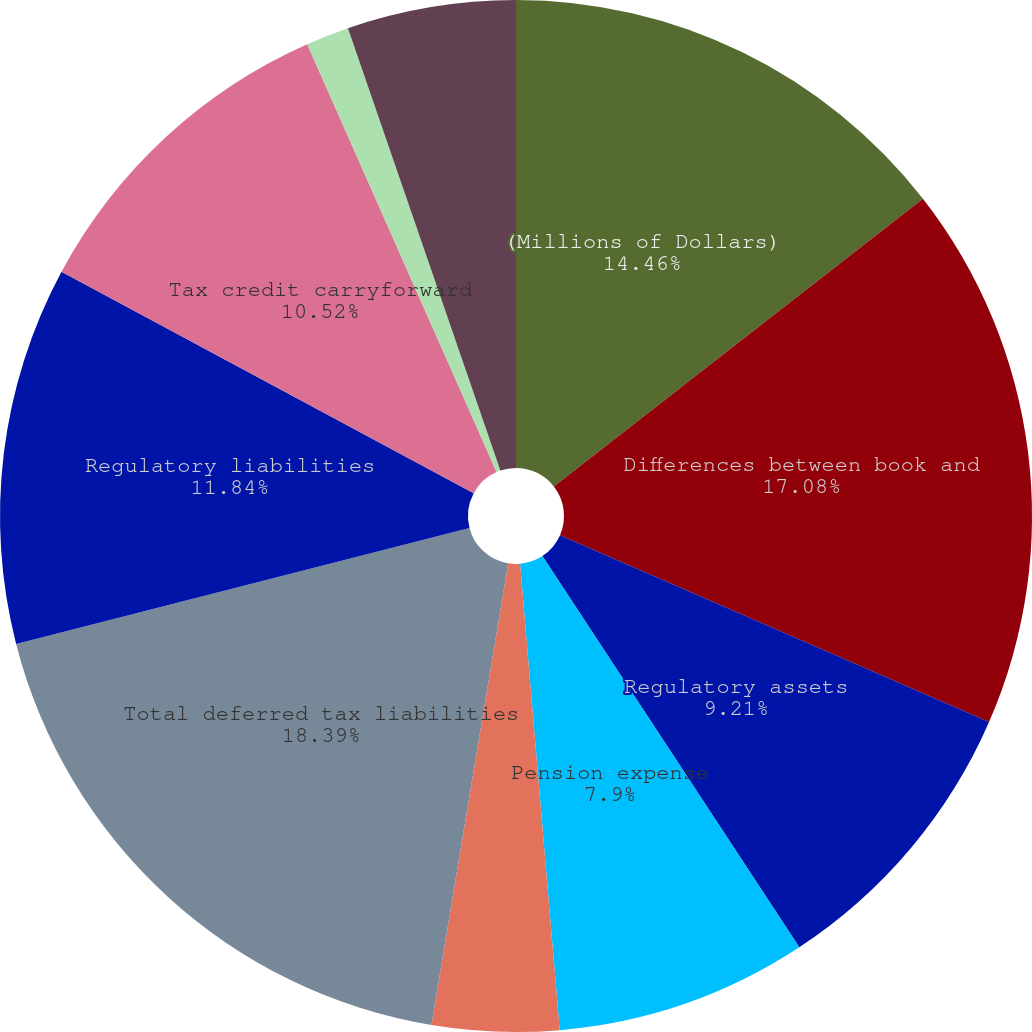Convert chart to OTSL. <chart><loc_0><loc_0><loc_500><loc_500><pie_chart><fcel>(Millions of Dollars)<fcel>Differences between book and<fcel>Regulatory assets<fcel>Pension expense<fcel>Other<fcel>Total deferred tax liabilities<fcel>Regulatory liabilities<fcel>Tax credit carryforward<fcel>NOL carryforward<fcel>NOL and tax credit valuation<nl><fcel>14.46%<fcel>17.08%<fcel>9.21%<fcel>7.9%<fcel>3.97%<fcel>18.39%<fcel>11.84%<fcel>10.52%<fcel>1.35%<fcel>5.28%<nl></chart> 